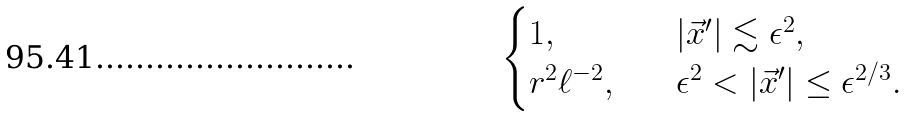Convert formula to latex. <formula><loc_0><loc_0><loc_500><loc_500>\begin{cases} 1 , \quad & | \vec { x } ^ { \prime } | \lesssim \epsilon ^ { 2 } , \\ r ^ { 2 } \ell ^ { - 2 } , \quad & \epsilon ^ { 2 } < | \vec { x } ^ { \prime } | \leq \epsilon ^ { 2 / 3 } . \end{cases}</formula> 